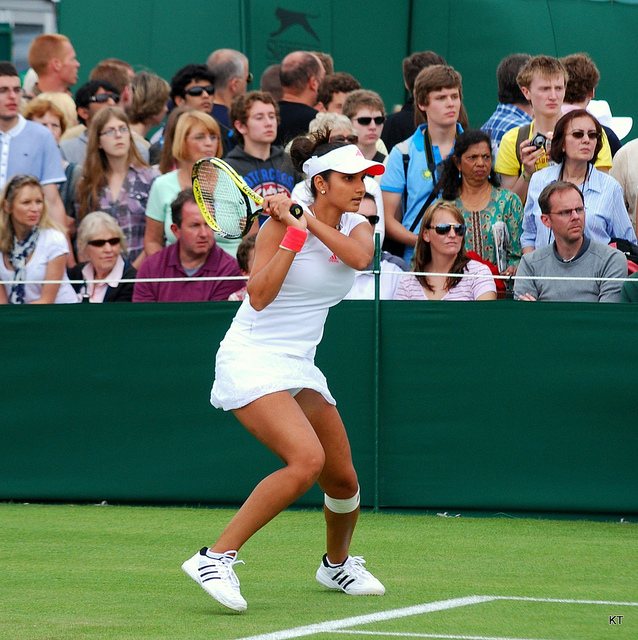<image>What lady in the crowd is pulling a crazy face? I don't know which lady in the crowd is pulling a crazy face. There are several descriptions mentioned such as 'one with short blonde hair', 'lady in striped shirt', 'woman in green', and 'short black hair green shirt'. However, multiple responses also indicate that no one is. What lady in the crowd is pulling a crazy face? There is no lady in the crowd pulling a crazy face. 